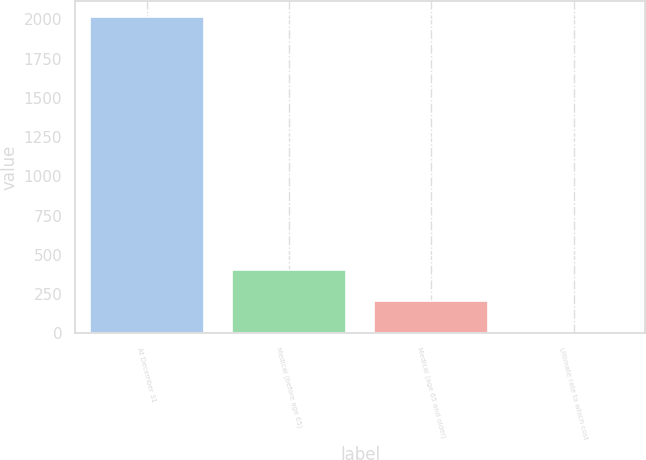Convert chart to OTSL. <chart><loc_0><loc_0><loc_500><loc_500><bar_chart><fcel>At December 31<fcel>Medical (before age 65)<fcel>Medical (age 65 and older)<fcel>Ultimate rate to which cost<nl><fcel>2015<fcel>406.6<fcel>205.55<fcel>4.5<nl></chart> 